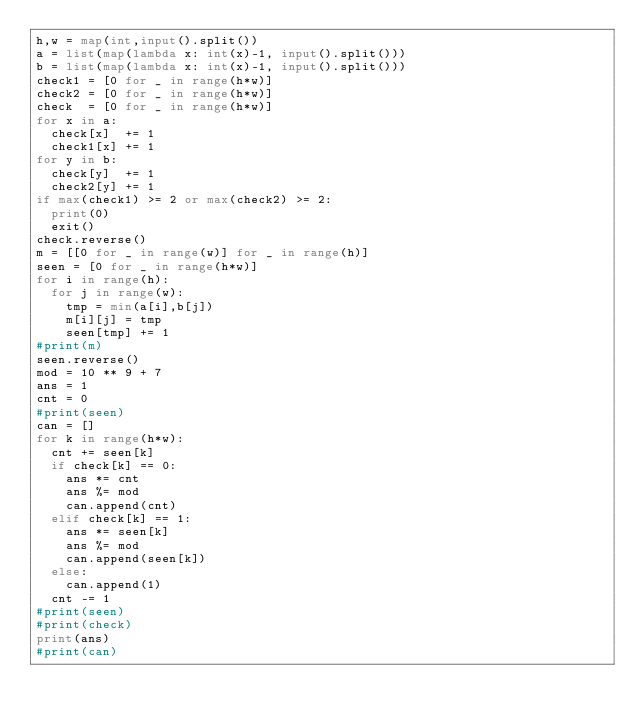<code> <loc_0><loc_0><loc_500><loc_500><_Python_>h,w = map(int,input().split())
a = list(map(lambda x: int(x)-1, input().split()))
b = list(map(lambda x: int(x)-1, input().split()))
check1 = [0 for _ in range(h*w)]
check2 = [0 for _ in range(h*w)]
check  = [0 for _ in range(h*w)]
for x in a:
  check[x]  += 1
  check1[x] += 1
for y in b:
  check[y]  += 1
  check2[y] += 1
if max(check1) >= 2 or max(check2) >= 2:
  print(0)
  exit()
check.reverse()
m = [[0 for _ in range(w)] for _ in range(h)]
seen = [0 for _ in range(h*w)]
for i in range(h):
  for j in range(w):
    tmp = min(a[i],b[j])
    m[i][j] = tmp
    seen[tmp] += 1
#print(m)
seen.reverse()
mod = 10 ** 9 + 7
ans = 1
cnt = 0
#print(seen)
can = []
for k in range(h*w):
  cnt += seen[k]
  if check[k] == 0:
    ans *= cnt
    ans %= mod
    can.append(cnt)
  elif check[k] == 1:
    ans *= seen[k]
    ans %= mod
    can.append(seen[k])
  else:
    can.append(1)
  cnt -= 1
#print(seen)
#print(check)
print(ans)
#print(can)</code> 